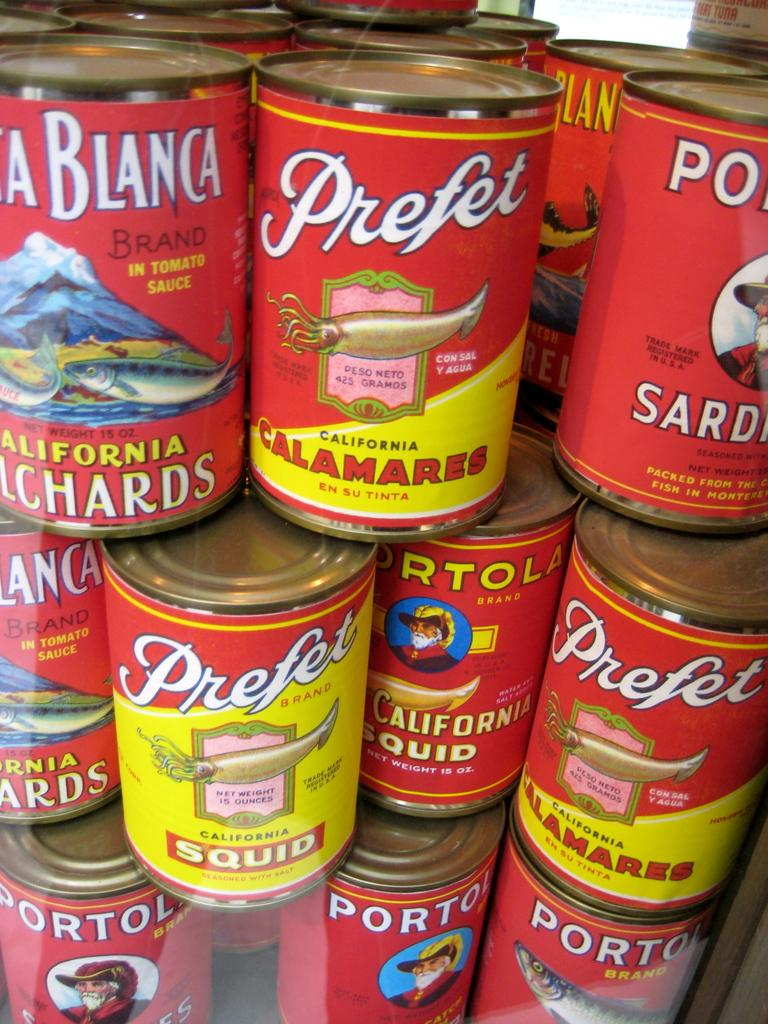<image>
Present a compact description of the photo's key features. Many cans of Prefet and Porto seafood are stacked together. 